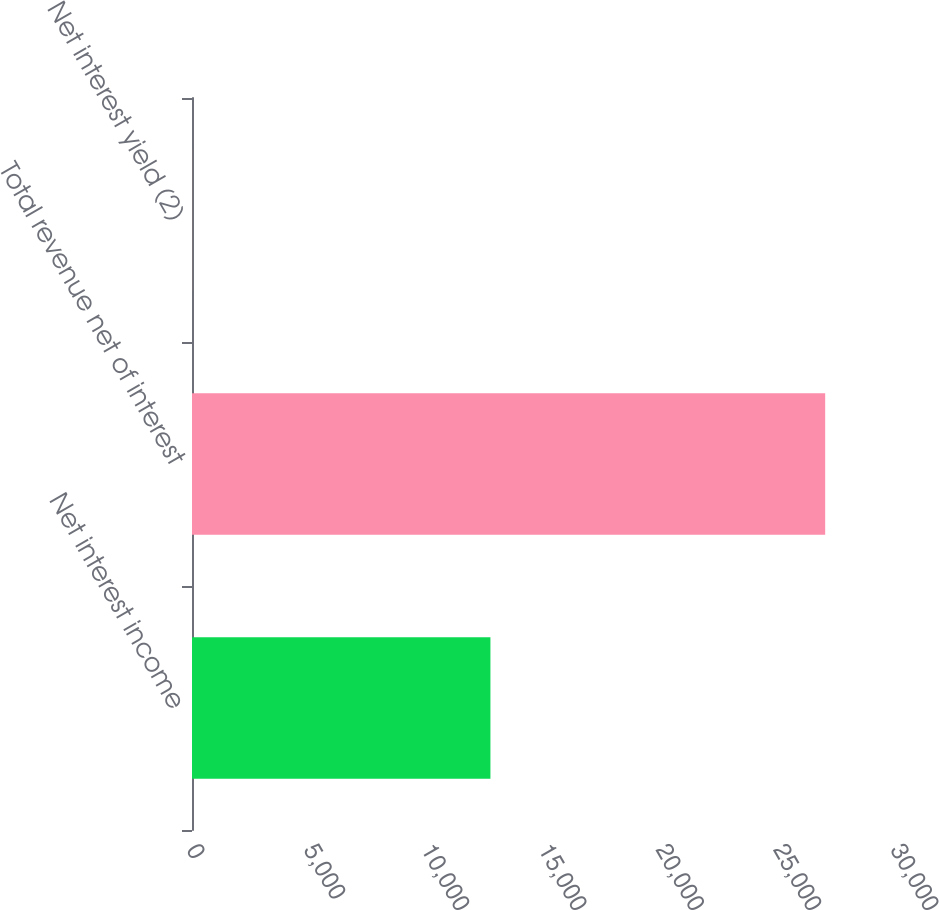Convert chart. <chart><loc_0><loc_0><loc_500><loc_500><bar_chart><fcel>Net interest income<fcel>Total revenue net of interest<fcel>Net interest yield (2)<nl><fcel>12717<fcel>26982<fcel>2.72<nl></chart> 